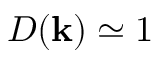Convert formula to latex. <formula><loc_0><loc_0><loc_500><loc_500>D ( k ) \simeq 1</formula> 